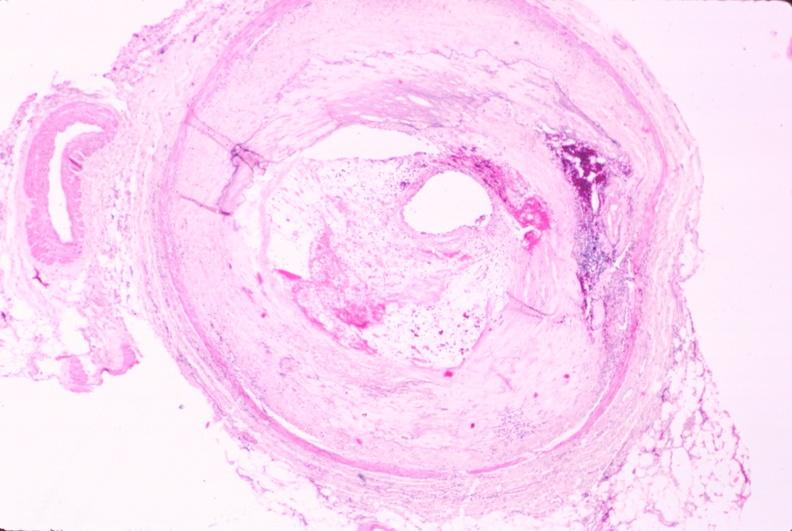what does this image show?
Answer the question using a single word or phrase. Atherosclerosis 